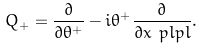<formula> <loc_0><loc_0><loc_500><loc_500>Q _ { + } & = \frac { \partial } { \partial \theta ^ { + } } - i \theta ^ { + } \frac { \partial } { \partial x ^ { \ } p l p l } .</formula> 